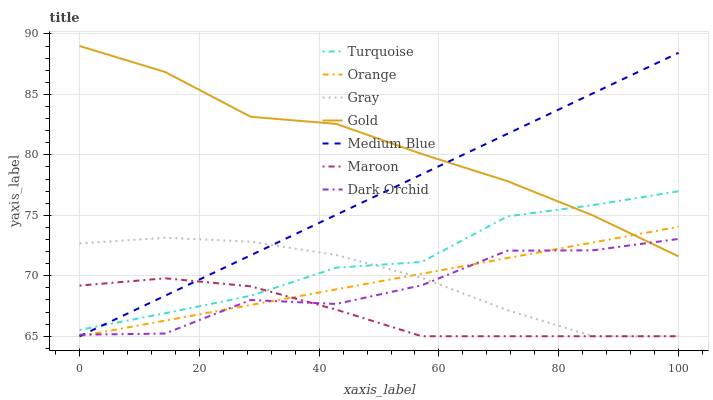Does Maroon have the minimum area under the curve?
Answer yes or no. Yes. Does Gold have the maximum area under the curve?
Answer yes or no. Yes. Does Turquoise have the minimum area under the curve?
Answer yes or no. No. Does Turquoise have the maximum area under the curve?
Answer yes or no. No. Is Orange the smoothest?
Answer yes or no. Yes. Is Dark Orchid the roughest?
Answer yes or no. Yes. Is Turquoise the smoothest?
Answer yes or no. No. Is Turquoise the roughest?
Answer yes or no. No. Does Gray have the lowest value?
Answer yes or no. Yes. Does Turquoise have the lowest value?
Answer yes or no. No. Does Gold have the highest value?
Answer yes or no. Yes. Does Turquoise have the highest value?
Answer yes or no. No. Is Maroon less than Gold?
Answer yes or no. Yes. Is Gold greater than Maroon?
Answer yes or no. Yes. Does Turquoise intersect Gray?
Answer yes or no. Yes. Is Turquoise less than Gray?
Answer yes or no. No. Is Turquoise greater than Gray?
Answer yes or no. No. Does Maroon intersect Gold?
Answer yes or no. No. 